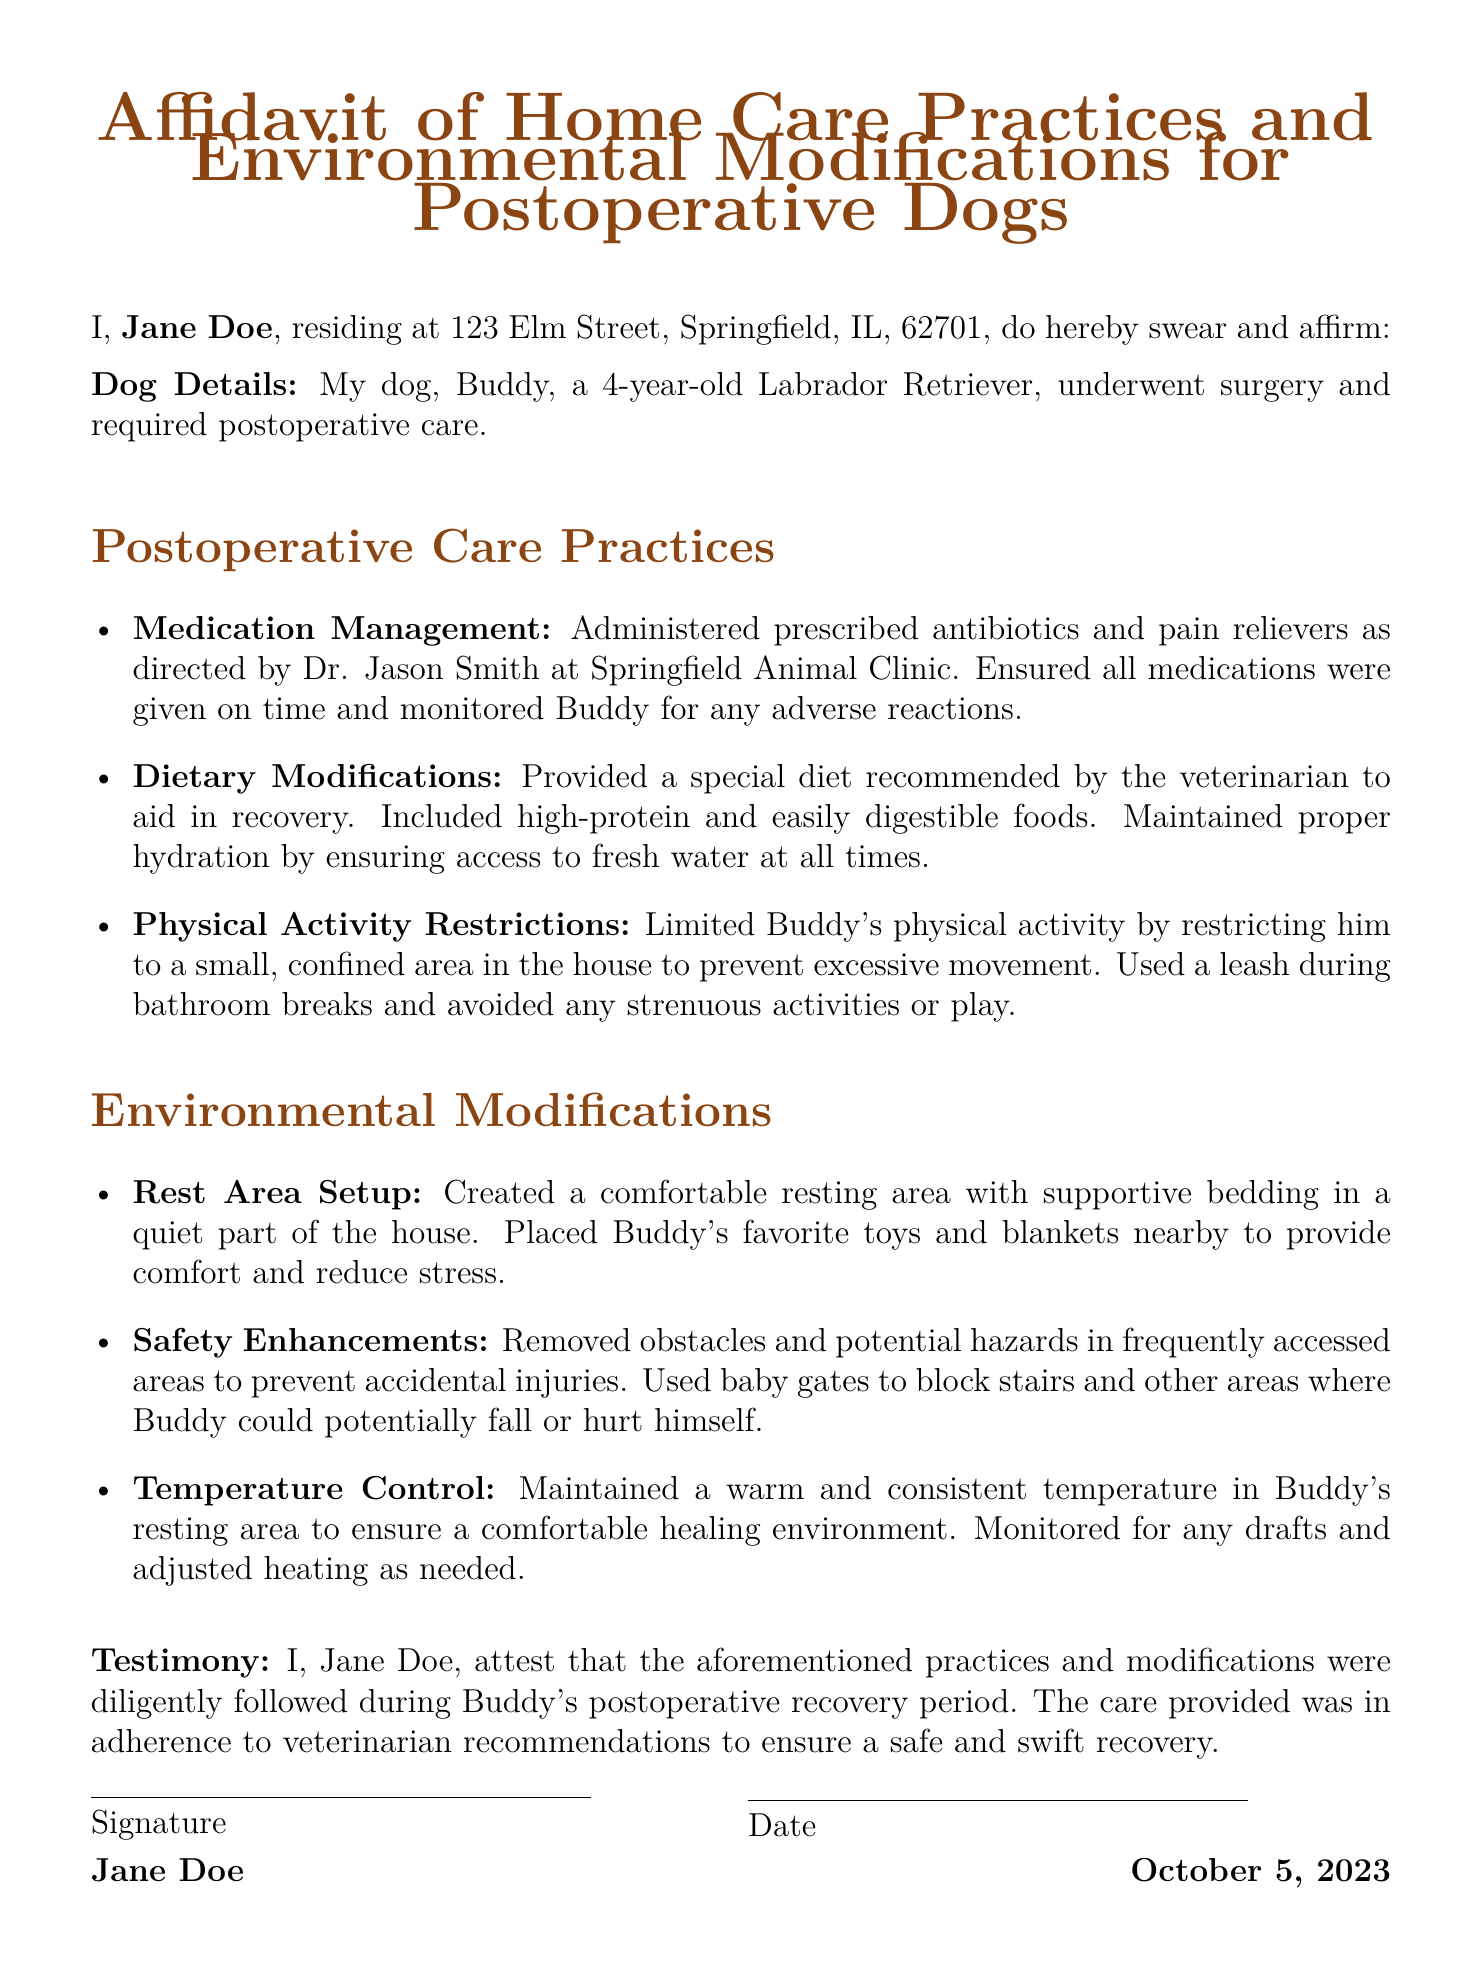What is the name of the dog? The document specifies that the dog is named Buddy.
Answer: Buddy Who is the veterinarian? The document mentions that Dr. Jason Smith is the veterinarian at Springfield Animal Clinic.
Answer: Dr. Jason Smith What type of modifications were made to Buddy's diet? The affidavit states that a special diet was provided, which included high-protein and easily digestible foods.
Answer: High-protein and easily digestible foods What is the purpose of the baby gates mentioned in the document? The baby gates are used to block stairs and prevent Buddy from falling or hurting himself.
Answer: Prevent Buddy from falling or hurting himself What was maintained in Buddy's resting area to ensure comfort? The affidavit indicates that a warm and consistent temperature was maintained in Buddy's resting area.
Answer: Warm and consistent temperature What should the affidavit not replace? The document advises that the affidavit is based on personal experience and should not replace professional veterinary advice.
Answer: Professional veterinary advice How old is Buddy? According to the affidavit, Buddy is a 4-year-old dog.
Answer: 4-year-old What date was the affidavit signed? The signature date mentioned in the document is October 5, 2023.
Answer: October 5, 2023 What type of document is this? The document is identified as an affidavit of home care practices and environmental modifications for postoperative dogs.
Answer: Affidavit of Home Care Practices and Environmental Modifications for Postoperative Dogs 